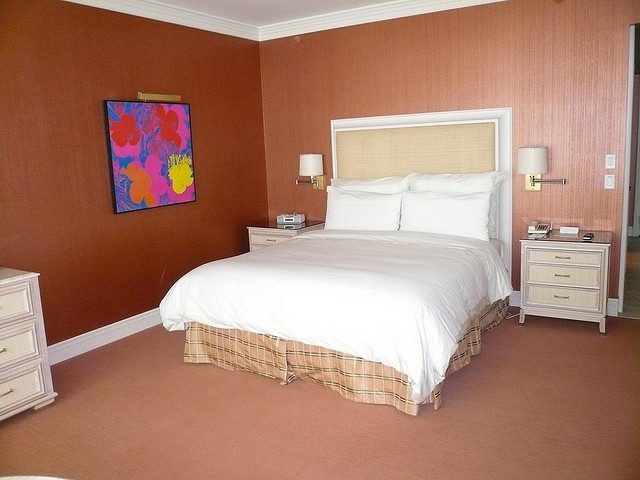Describe the objects in this image and their specific colors. I can see bed in maroon, white, tan, and darkgray tones and remote in maroon, black, gray, and darkgray tones in this image. 